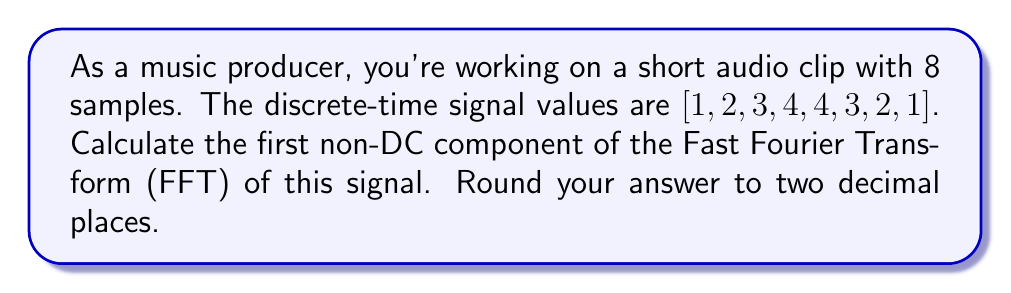Teach me how to tackle this problem. To calculate the FFT of the given discrete audio signal, we'll follow these steps:

1) The FFT for a signal with N samples is given by:

   $$X_k = \sum_{n=0}^{N-1} x_n e^{-i2\pi kn/N}$$

   where $k = 0, 1, ..., N-1$

2) We're asked for the first non-DC component, which is $X_1$. So, we'll calculate:

   $$X_1 = \sum_{n=0}^{7} x_n e^{-i2\pi n/8}$$

3) Expand this sum:

   $$X_1 = 1e^{-i2\pi(0)/8} + 2e^{-i2\pi(1)/8} + 3e^{-i2\pi(2)/8} + 4e^{-i2\pi(3)/8} + 4e^{-i2\pi(4)/8} + 3e^{-i2\pi(5)/8} + 2e^{-i2\pi(6)/8} + 1e^{-i2\pi(7)/8}$$

4) Simplify the exponents:

   $$X_1 = 1 + 2e^{-i\pi/4} + 3e^{-i\pi/2} + 4e^{-i3\pi/4} + 4e^{-i\pi} + 3e^{-i5\pi/4} + 2e^{-i3\pi/2} + 1e^{-i7\pi/4}$$

5) Convert to trigonometric form:

   $$X_1 = 1 + 2(\frac{\sqrt{2}}{2} - i\frac{\sqrt{2}}{2}) + 3(-i) + 4(-\frac{\sqrt{2}}{2} - i\frac{\sqrt{2}}{2}) + 4(-1) + 3(-\frac{\sqrt{2}}{2} + i\frac{\sqrt{2}}{2}) + 2(i) + 1(\frac{\sqrt{2}}{2} + i\frac{\sqrt{2}}{2})$$

6) Separate real and imaginary parts:

   $$X_1 = (1 + 2\frac{\sqrt{2}}{2} - 4\frac{\sqrt{2}}{2} - 4 - 3\frac{\sqrt{2}}{2} + \frac{\sqrt{2}}{2}) + i(-2\frac{\sqrt{2}}{2} - 3 - 4\frac{\sqrt{2}}{2} + 3\frac{\sqrt{2}}{2} + 2 + \frac{\sqrt{2}}{2})$$

7) Simplify:

   $$X_1 = (-4 - 3\frac{\sqrt{2}}{2}) + i(-1 - 3\frac{\sqrt{2}}{2})$$

8) Calculate magnitude:

   $$|X_1| = \sqrt{(-4 - 3\frac{\sqrt{2}}{2})^2 + (-1 - 3\frac{\sqrt{2}}{2})^2} \approx 5.66$$
Answer: $5.66$ 